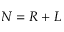Convert formula to latex. <formula><loc_0><loc_0><loc_500><loc_500>N = R + L</formula> 